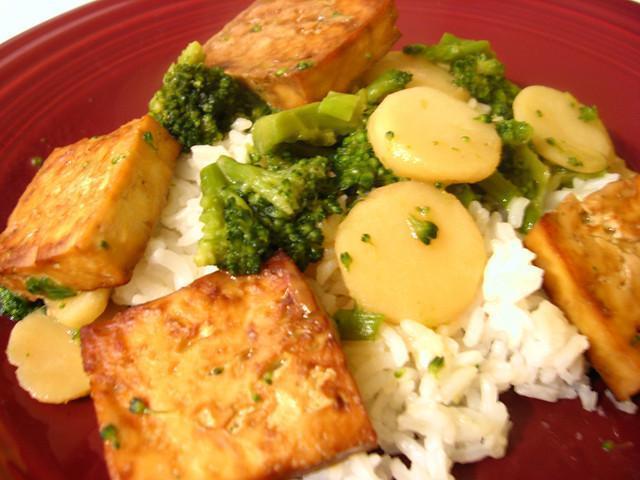Which item on the plate is highest in carbs?
Select the accurate answer and provide justification: `Answer: choice
Rationale: srationale.`
Options: Broccoli, squash, rice, meat. Answer: rice.
Rationale: The rice is high in carbs. 